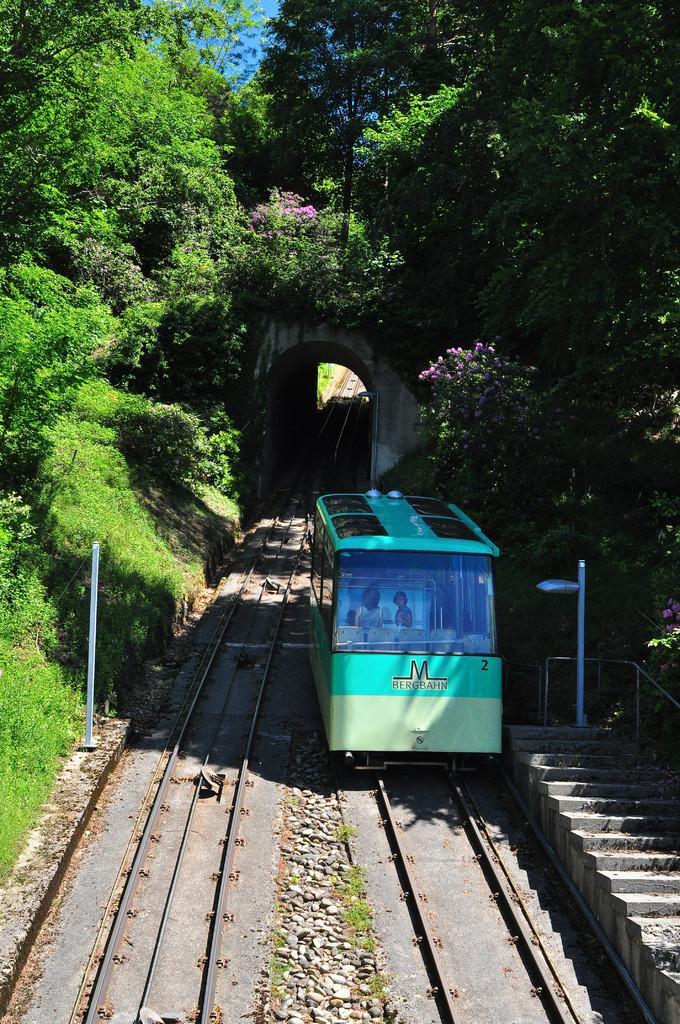How would you summarize this image in a sentence or two? In this image we can see a locomotive on the track and some people sitting inside it. We can also see some stones, grass, the staircase, plants, a street pole, a pole with wires, an arch, a group of trees and the sky. 